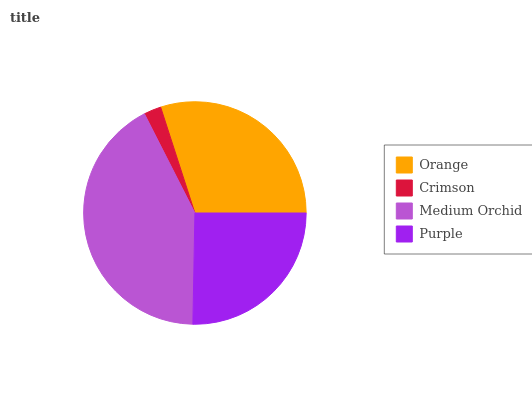Is Crimson the minimum?
Answer yes or no. Yes. Is Medium Orchid the maximum?
Answer yes or no. Yes. Is Medium Orchid the minimum?
Answer yes or no. No. Is Crimson the maximum?
Answer yes or no. No. Is Medium Orchid greater than Crimson?
Answer yes or no. Yes. Is Crimson less than Medium Orchid?
Answer yes or no. Yes. Is Crimson greater than Medium Orchid?
Answer yes or no. No. Is Medium Orchid less than Crimson?
Answer yes or no. No. Is Orange the high median?
Answer yes or no. Yes. Is Purple the low median?
Answer yes or no. Yes. Is Purple the high median?
Answer yes or no. No. Is Crimson the low median?
Answer yes or no. No. 